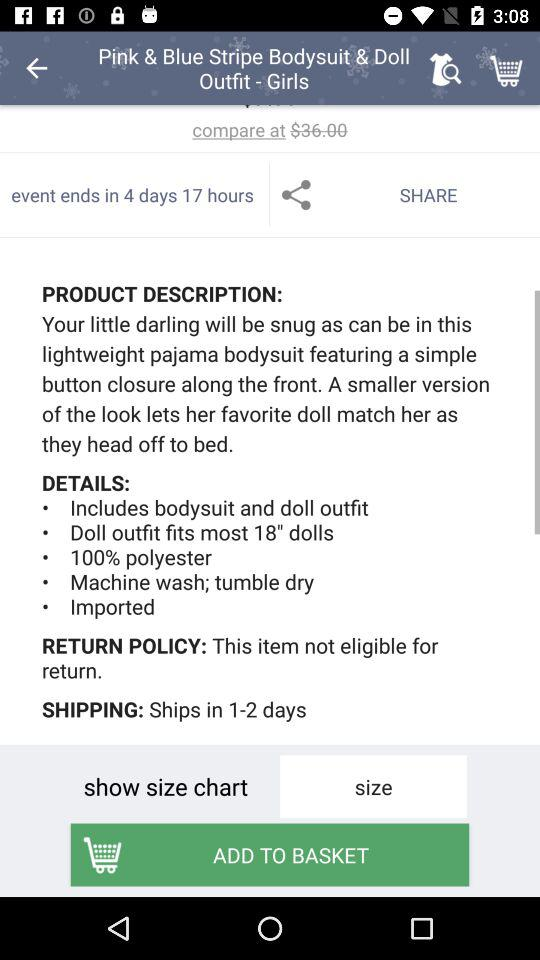What is the amount mentioned in the phrase "compare at"? The mentioned amount is $36. 